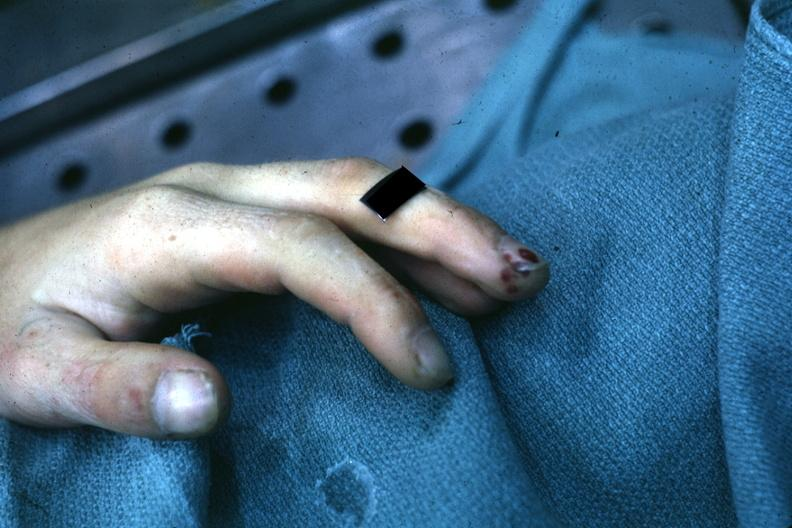what does this image show?
Answer the question using a single word or phrase. Very good example of focal necrotizing lesions in distal portion of digit associated with bacterial endocarditis 